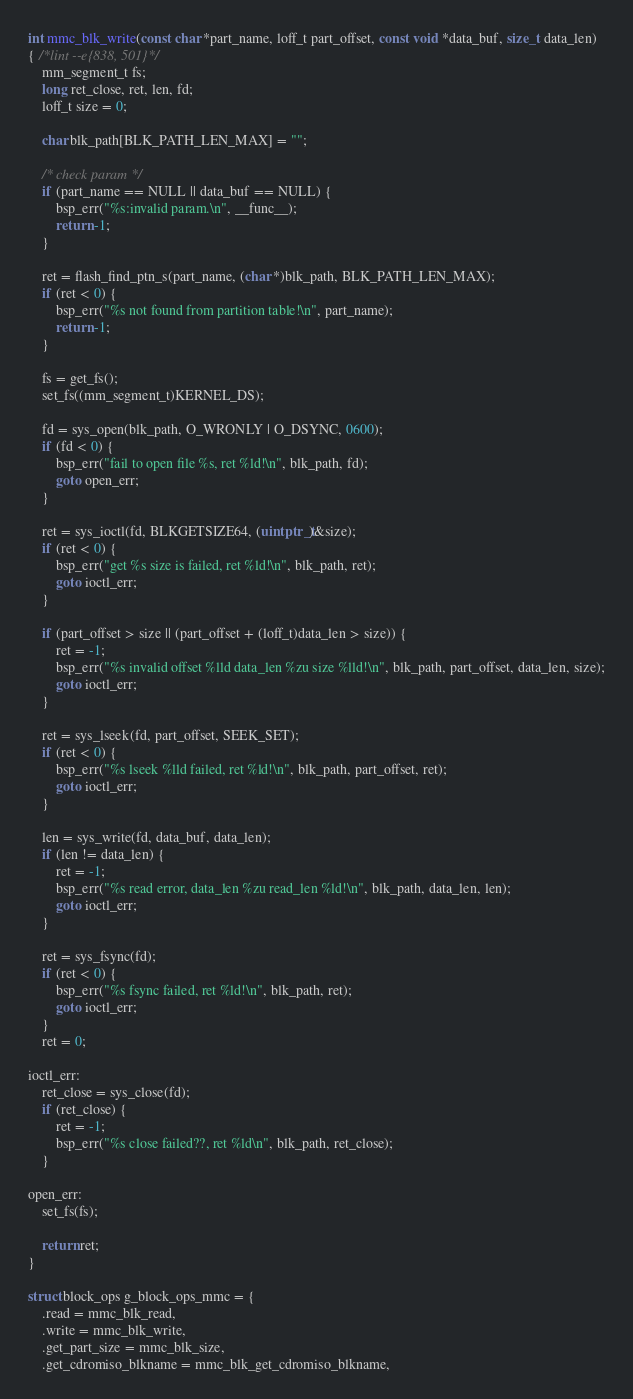Convert code to text. <code><loc_0><loc_0><loc_500><loc_500><_C_>
int mmc_blk_write(const char *part_name, loff_t part_offset, const void *data_buf, size_t data_len)
{ /*lint --e{838, 501}*/
    mm_segment_t fs;
    long ret_close, ret, len, fd;
    loff_t size = 0;

    char blk_path[BLK_PATH_LEN_MAX] = "";

    /* check param */
    if (part_name == NULL || data_buf == NULL) {
        bsp_err("%s:invalid param.\n", __func__);
        return -1;
    }

    ret = flash_find_ptn_s(part_name, (char *)blk_path, BLK_PATH_LEN_MAX);
    if (ret < 0) {
        bsp_err("%s not found from partition table!\n", part_name);
        return -1;
    }

    fs = get_fs();
    set_fs((mm_segment_t)KERNEL_DS);

    fd = sys_open(blk_path, O_WRONLY | O_DSYNC, 0600);
    if (fd < 0) {
        bsp_err("fail to open file %s, ret %ld!\n", blk_path, fd);
        goto open_err;
    }

    ret = sys_ioctl(fd, BLKGETSIZE64, (uintptr_t)&size);
    if (ret < 0) {
        bsp_err("get %s size is failed, ret %ld!\n", blk_path, ret);
        goto ioctl_err;
    }

    if (part_offset > size || (part_offset + (loff_t)data_len > size)) {
        ret = -1;
        bsp_err("%s invalid offset %lld data_len %zu size %lld!\n", blk_path, part_offset, data_len, size);
        goto ioctl_err;
    }

    ret = sys_lseek(fd, part_offset, SEEK_SET);
    if (ret < 0) {
        bsp_err("%s lseek %lld failed, ret %ld!\n", blk_path, part_offset, ret);
        goto ioctl_err;
    }

    len = sys_write(fd, data_buf, data_len);
    if (len != data_len) {
        ret = -1;
        bsp_err("%s read error, data_len %zu read_len %ld!\n", blk_path, data_len, len);
        goto ioctl_err;
    }

    ret = sys_fsync(fd);
    if (ret < 0) {
        bsp_err("%s fsync failed, ret %ld!\n", blk_path, ret);
        goto ioctl_err;
    }
    ret = 0;

ioctl_err:
    ret_close = sys_close(fd);
    if (ret_close) {
        ret = -1;
        bsp_err("%s close failed??, ret %ld\n", blk_path, ret_close);
    }

open_err:
    set_fs(fs);

    return ret;
}

struct block_ops g_block_ops_mmc = {
    .read = mmc_blk_read,
    .write = mmc_blk_write,
    .get_part_size = mmc_blk_size,
    .get_cdromiso_blkname = mmc_blk_get_cdromiso_blkname,</code> 